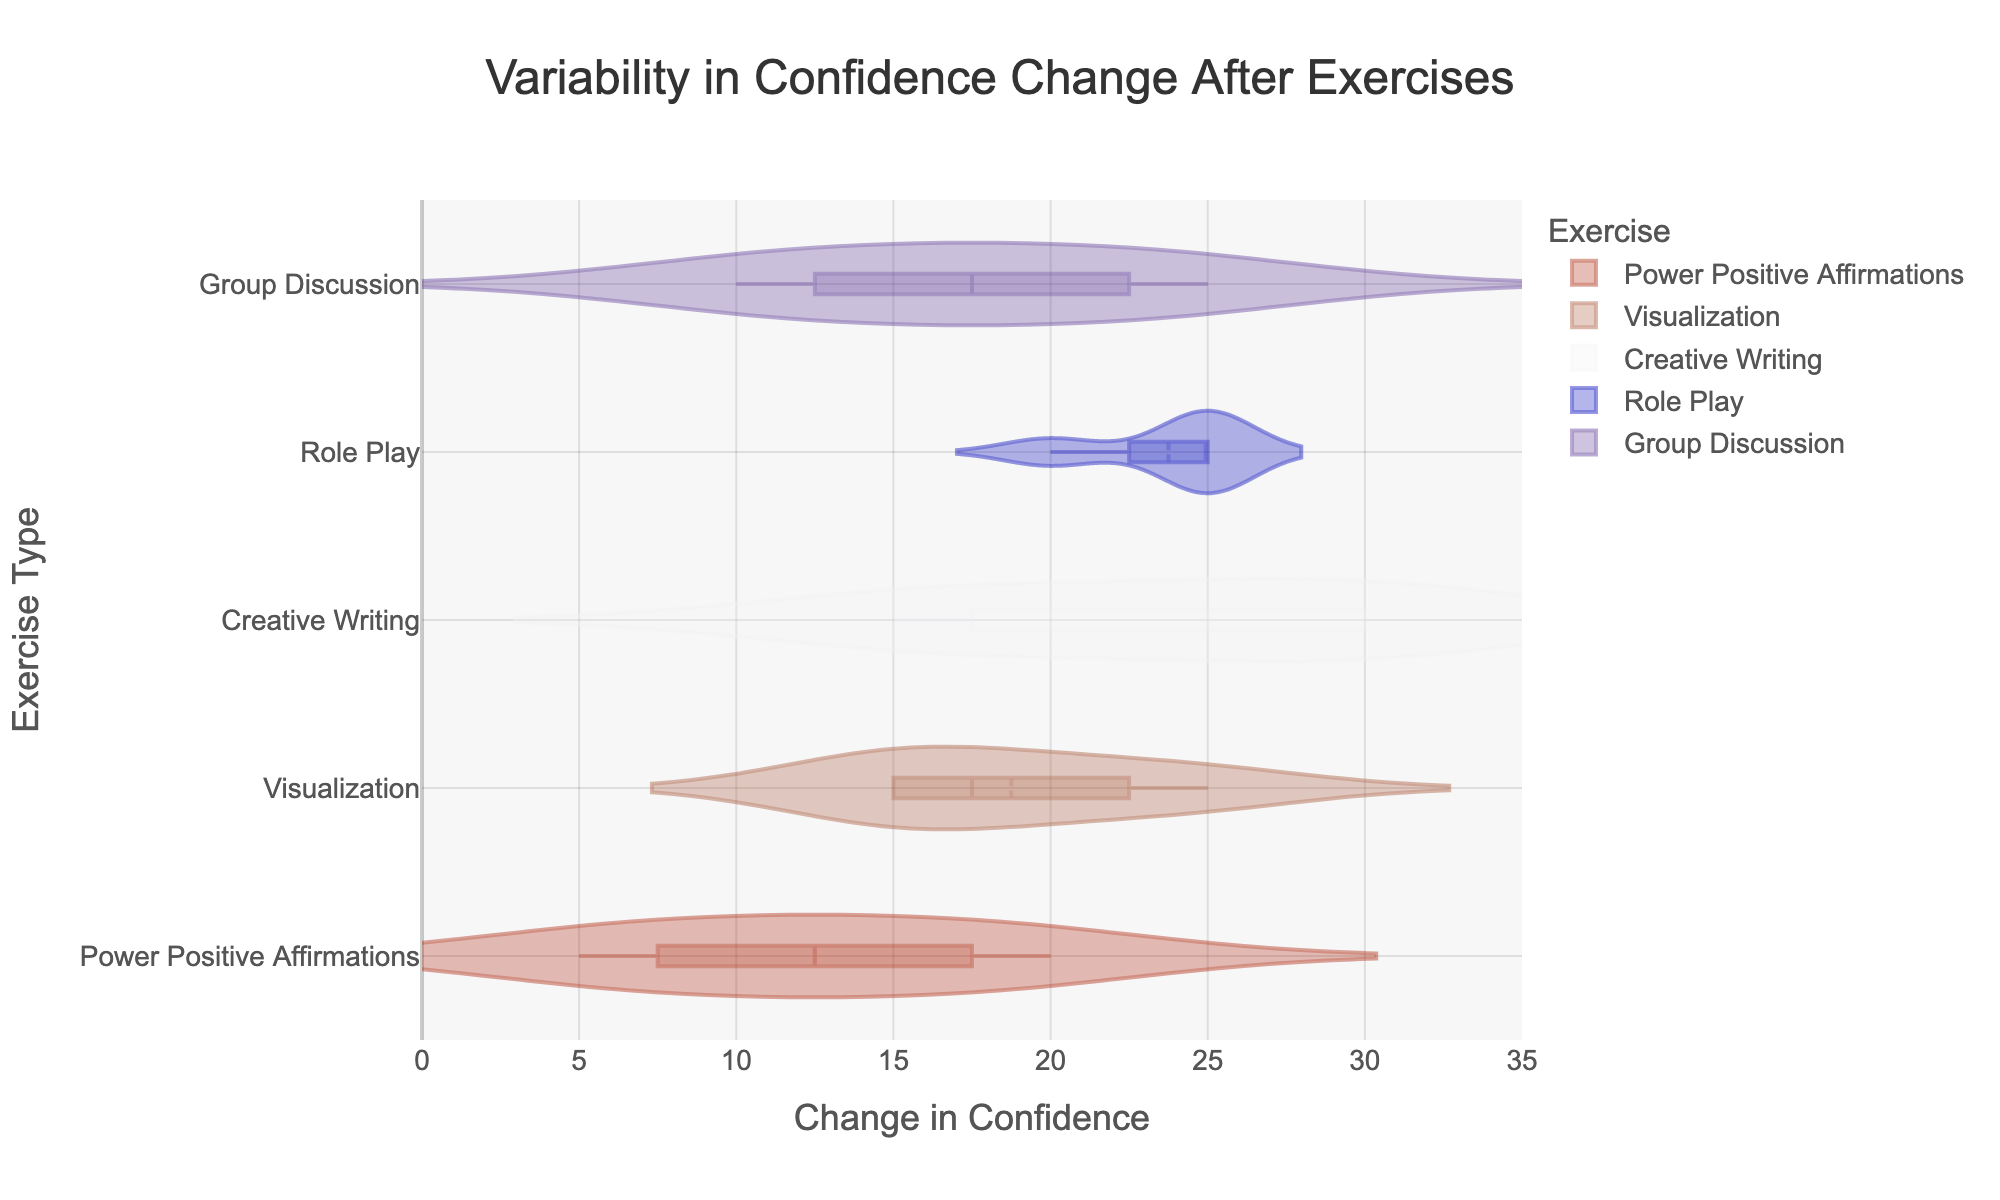What is the title of the figure? The title is the text at the top of the figure. It typically provides a summary of what the figure is about.
Answer: Variability in Confidence Change After Exercises What does the x-axis represent? The x-axis title is "Change in Confidence," indicating it represents the range of change in confidence levels among teenagers after exercises.
Answer: Change in Confidence Which exercise has the highest mean confidence change? Each exercise's mean confidence change is represented by a line in the middle of the violin plot. Find the one with the highest line.
Answer: Creative Writing What is the range of confidence change for Power Positive Affirmations? Look at the total spread of the violin plot for Power Positive Affirmations.
Answer: 0 to 20 Which exercise shows the most variability in confidence change? The exercise with the widest spread in its violin plot has the most variability.
Answer: Role Play How does the median confidence change for Visualization compare to Creative Writing? The median is shown by a line inside the violin plot. Compare the lines for Visualization and Creative Writing.
Answer: The median for Creative Writing is higher Which exercise had minimal confidence change close to its mean value? Exercises with tightly clustered points around their mean line show minimal variability.
Answer: Power Positive Affirmations Is there any exercise where no teenager experienced a decrease in confidence? Look for violin plots where the lower bound is exactly at 0 or higher.
Answer: All exercises By looking at the y-axis, how many types of exercises are compared? The y-axis lists each unique exercise type. Count the distinct labels.
Answer: 5 